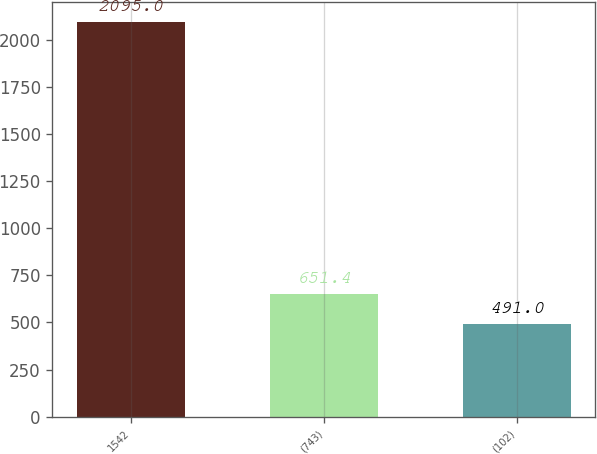Convert chart to OTSL. <chart><loc_0><loc_0><loc_500><loc_500><bar_chart><fcel>1542<fcel>(743)<fcel>(102)<nl><fcel>2095<fcel>651.4<fcel>491<nl></chart> 